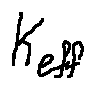<formula> <loc_0><loc_0><loc_500><loc_500>k _ { e f f }</formula> 